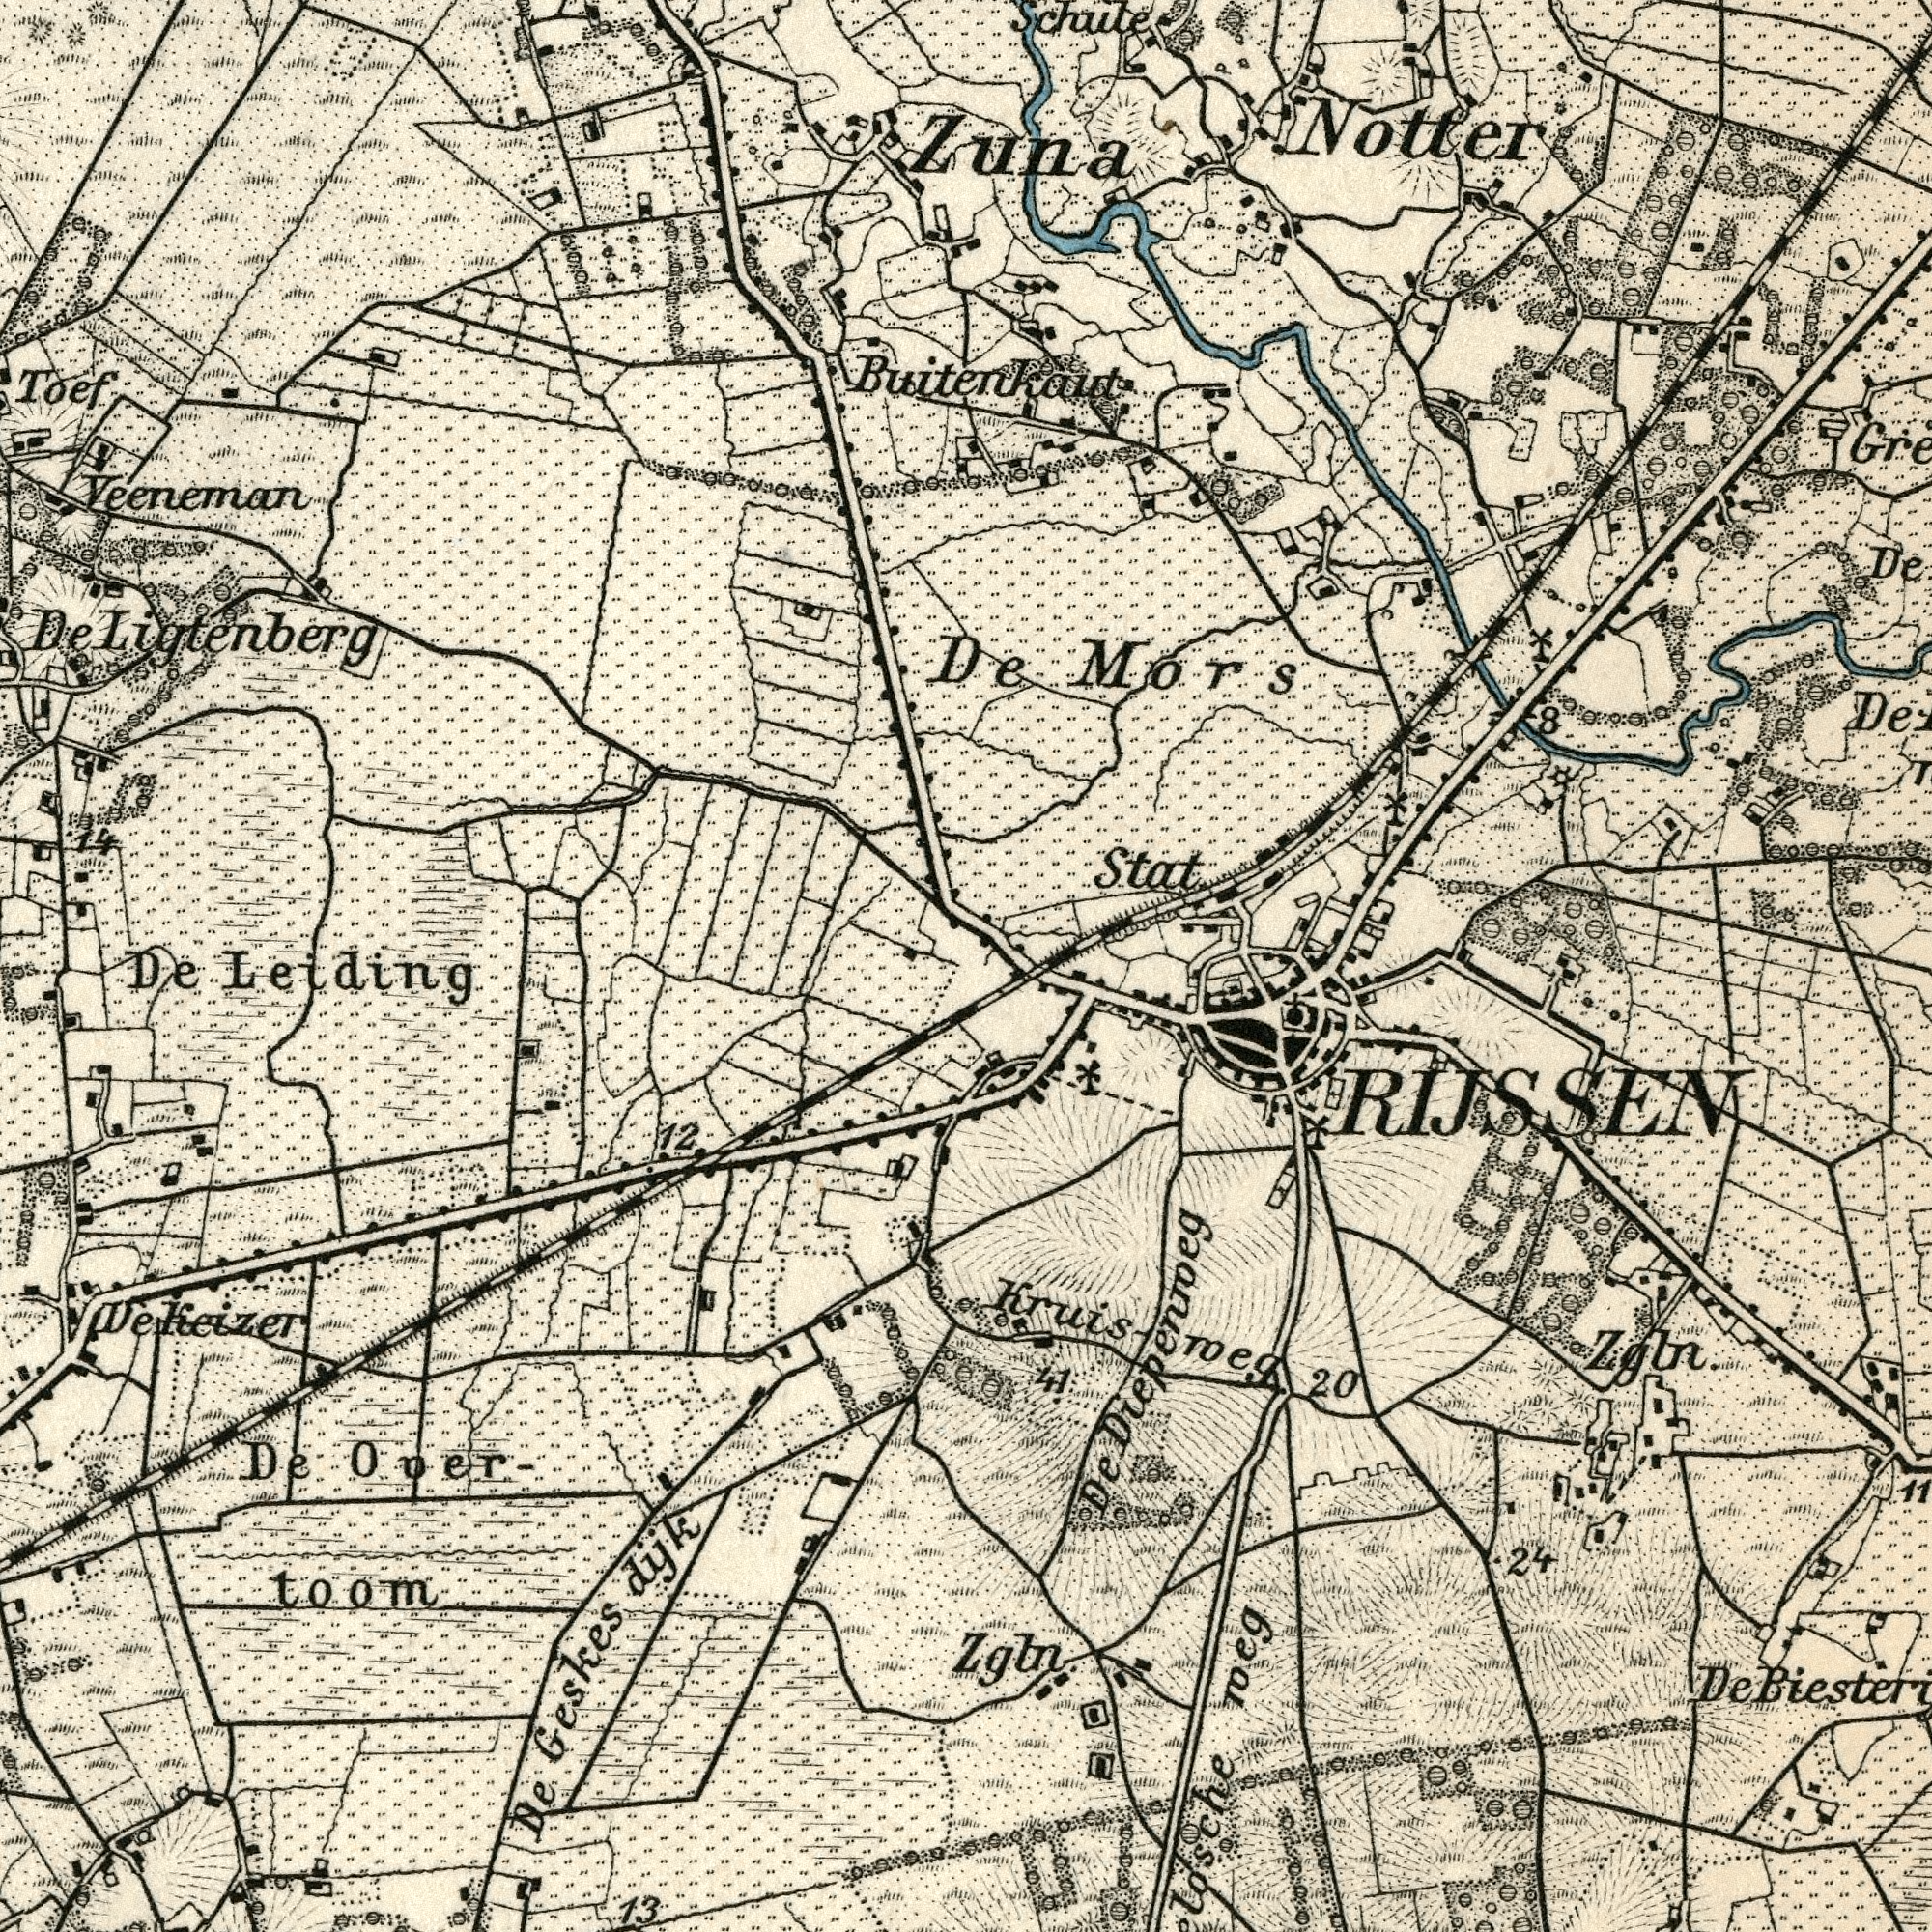What text is visible in the upper-right corner? Buitenkaut Schule De Notter De Mors Stat Zuna 8 What text appears in the bottom-right area of the image? 24 Zgln Kruisroeg De 20 41 Zgln 11 Losche roeg De Diepenroeg RIJSSEN What text is visible in the upper-left corner? Toef 14 De Ligtenberg Veeneman What text is visible in the lower-left corner? De Geskes dyk De Leiding De Over- toom 12 13 Dekeizer 